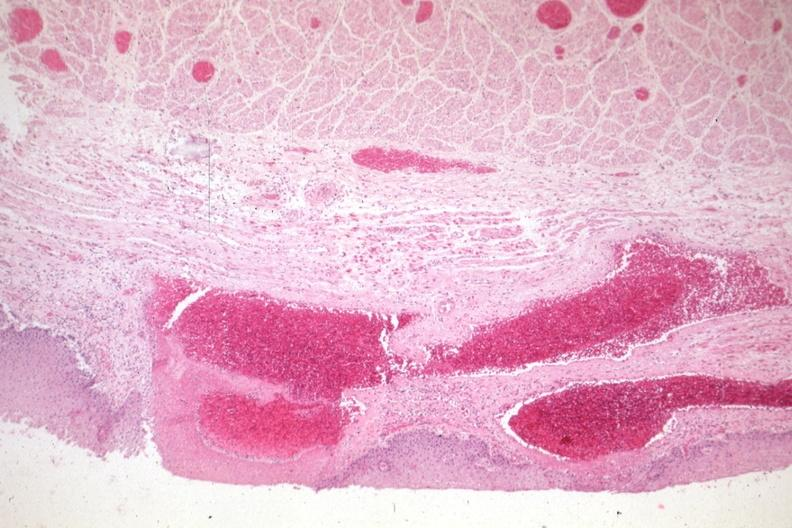s stillborn cord around neck present?
Answer the question using a single word or phrase. No 